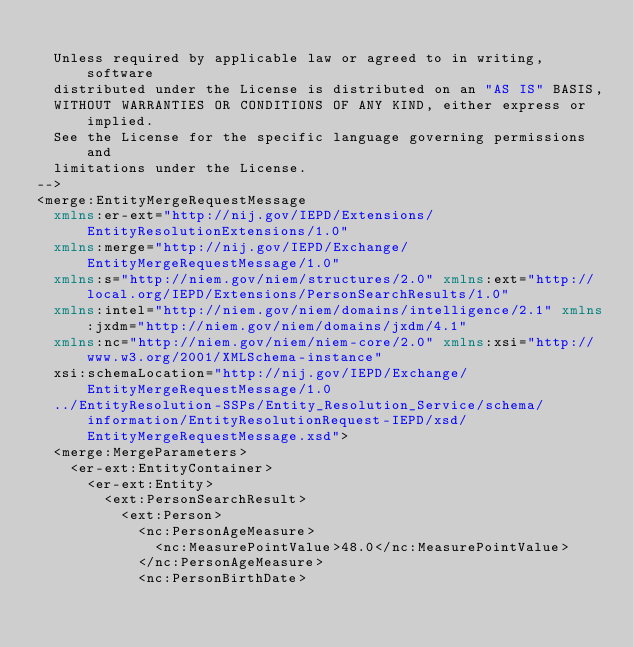Convert code to text. <code><loc_0><loc_0><loc_500><loc_500><_XML_>  
  Unless required by applicable law or agreed to in writing, software
  distributed under the License is distributed on an "AS IS" BASIS, 
  WITHOUT WARRANTIES OR CONDITIONS OF ANY KIND, either express or implied.
  See the License for the specific language governing permissions and
  limitations under the License.
-->
<merge:EntityMergeRequestMessage
	xmlns:er-ext="http://nij.gov/IEPD/Extensions/EntityResolutionExtensions/1.0"
	xmlns:merge="http://nij.gov/IEPD/Exchange/EntityMergeRequestMessage/1.0"
	xmlns:s="http://niem.gov/niem/structures/2.0" xmlns:ext="http://local.org/IEPD/Extensions/PersonSearchResults/1.0"
	xmlns:intel="http://niem.gov/niem/domains/intelligence/2.1" xmlns:jxdm="http://niem.gov/niem/domains/jxdm/4.1"
	xmlns:nc="http://niem.gov/niem/niem-core/2.0" xmlns:xsi="http://www.w3.org/2001/XMLSchema-instance"
	xsi:schemaLocation="http://nij.gov/IEPD/Exchange/EntityMergeRequestMessage/1.0
	../EntityResolution-SSPs/Entity_Resolution_Service/schema/information/EntityResolutionRequest-IEPD/xsd/EntityMergeRequestMessage.xsd">
	<merge:MergeParameters>
		<er-ext:EntityContainer>
			<er-ext:Entity>
				<ext:PersonSearchResult>
					<ext:Person>
						<nc:PersonAgeMeasure>
							<nc:MeasurePointValue>48.0</nc:MeasurePointValue>
						</nc:PersonAgeMeasure>
						<nc:PersonBirthDate></code> 